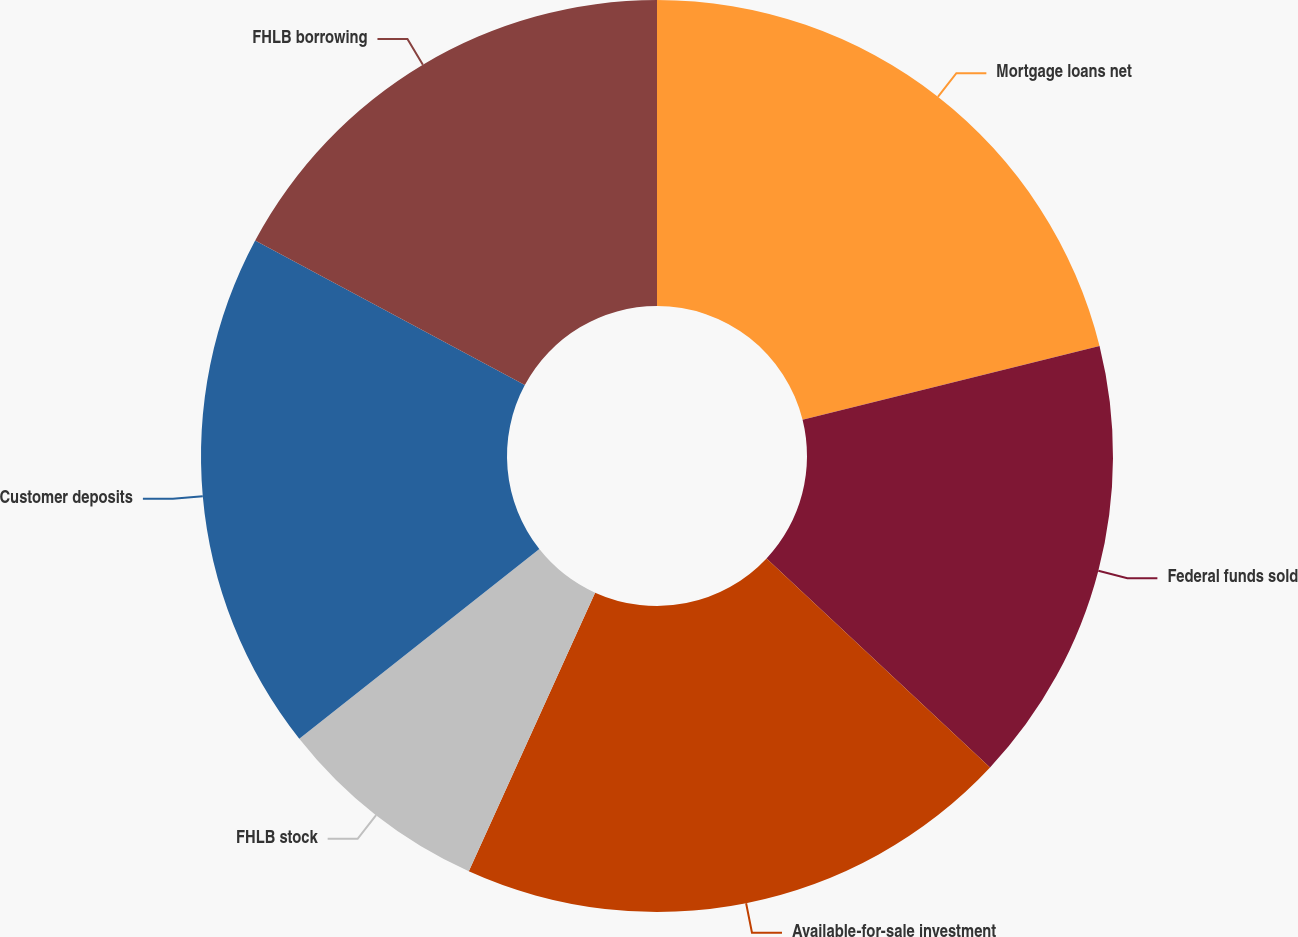<chart> <loc_0><loc_0><loc_500><loc_500><pie_chart><fcel>Mortgage loans net<fcel>Federal funds sold<fcel>Available-for-sale investment<fcel>FHLB stock<fcel>Customer deposits<fcel>FHLB borrowing<nl><fcel>21.12%<fcel>15.84%<fcel>19.8%<fcel>7.58%<fcel>18.48%<fcel>17.16%<nl></chart> 